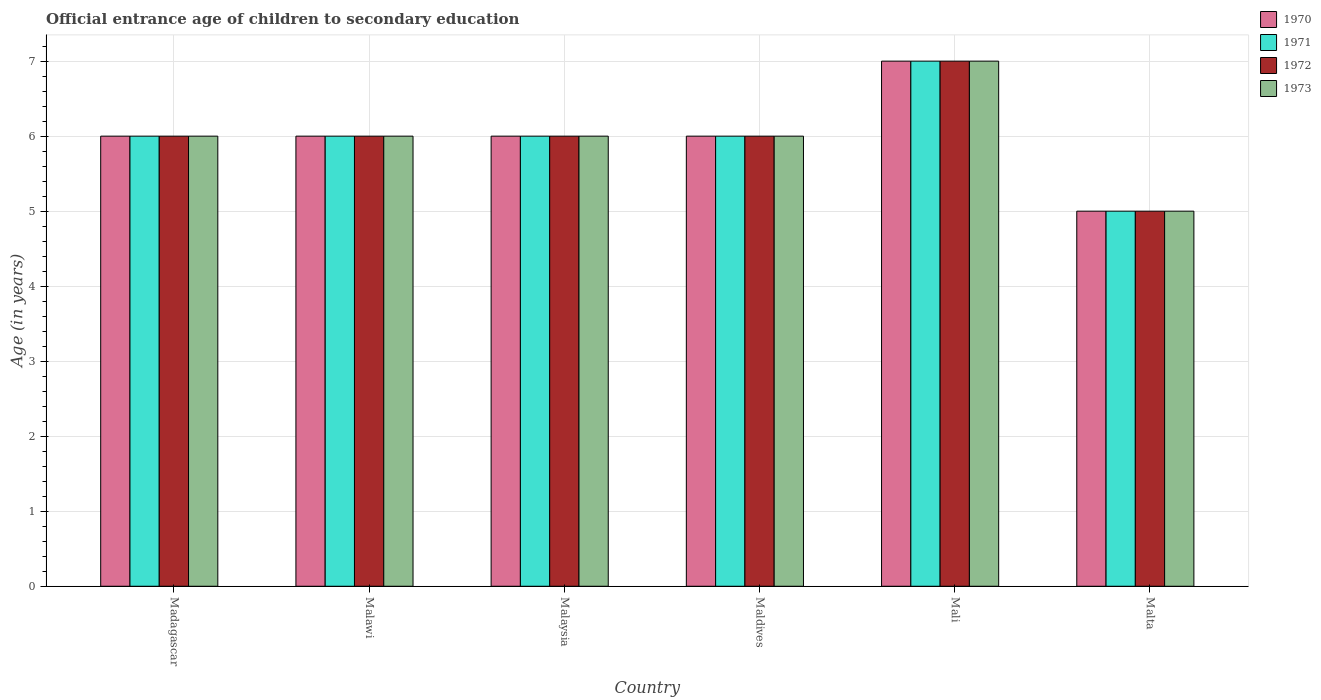How many bars are there on the 3rd tick from the right?
Provide a short and direct response. 4. What is the label of the 2nd group of bars from the left?
Offer a very short reply. Malawi. What is the secondary school starting age of children in 1972 in Madagascar?
Provide a succinct answer. 6. In which country was the secondary school starting age of children in 1972 maximum?
Your answer should be very brief. Mali. In which country was the secondary school starting age of children in 1971 minimum?
Provide a short and direct response. Malta. What is the average secondary school starting age of children in 1972 per country?
Your answer should be compact. 6. What is the difference between the secondary school starting age of children of/in 1972 and secondary school starting age of children of/in 1970 in Maldives?
Provide a short and direct response. 0. In how many countries, is the secondary school starting age of children in 1972 greater than 2 years?
Give a very brief answer. 6. What is the ratio of the secondary school starting age of children in 1972 in Malawi to that in Mali?
Your answer should be compact. 0.86. Is the secondary school starting age of children in 1972 in Madagascar less than that in Malta?
Your answer should be compact. No. Is the difference between the secondary school starting age of children in 1972 in Madagascar and Malaysia greater than the difference between the secondary school starting age of children in 1970 in Madagascar and Malaysia?
Your answer should be very brief. No. What is the difference between the highest and the second highest secondary school starting age of children in 1972?
Provide a succinct answer. -1. What is the difference between the highest and the lowest secondary school starting age of children in 1973?
Ensure brevity in your answer.  2. Is the sum of the secondary school starting age of children in 1973 in Malaysia and Maldives greater than the maximum secondary school starting age of children in 1972 across all countries?
Provide a succinct answer. Yes. Is it the case that in every country, the sum of the secondary school starting age of children in 1973 and secondary school starting age of children in 1970 is greater than the sum of secondary school starting age of children in 1972 and secondary school starting age of children in 1971?
Your answer should be compact. No. What does the 3rd bar from the right in Malaysia represents?
Keep it short and to the point. 1971. Are all the bars in the graph horizontal?
Make the answer very short. No. What is the difference between two consecutive major ticks on the Y-axis?
Offer a terse response. 1. Does the graph contain grids?
Make the answer very short. Yes. Where does the legend appear in the graph?
Provide a succinct answer. Top right. How many legend labels are there?
Your answer should be compact. 4. How are the legend labels stacked?
Offer a very short reply. Vertical. What is the title of the graph?
Provide a succinct answer. Official entrance age of children to secondary education. Does "1981" appear as one of the legend labels in the graph?
Offer a terse response. No. What is the label or title of the Y-axis?
Make the answer very short. Age (in years). What is the Age (in years) of 1970 in Madagascar?
Your answer should be very brief. 6. What is the Age (in years) in 1971 in Madagascar?
Your response must be concise. 6. What is the Age (in years) of 1973 in Madagascar?
Your answer should be very brief. 6. What is the Age (in years) in 1970 in Malawi?
Your response must be concise. 6. What is the Age (in years) in 1973 in Malawi?
Offer a terse response. 6. What is the Age (in years) in 1973 in Malaysia?
Provide a short and direct response. 6. What is the Age (in years) of 1971 in Maldives?
Your answer should be compact. 6. What is the Age (in years) in 1972 in Maldives?
Your answer should be very brief. 6. What is the Age (in years) in 1973 in Maldives?
Your answer should be compact. 6. What is the Age (in years) of 1971 in Mali?
Make the answer very short. 7. What is the Age (in years) in 1972 in Mali?
Offer a terse response. 7. What is the Age (in years) of 1973 in Mali?
Provide a succinct answer. 7. What is the Age (in years) in 1970 in Malta?
Offer a very short reply. 5. What is the Age (in years) of 1973 in Malta?
Your response must be concise. 5. Across all countries, what is the maximum Age (in years) in 1973?
Make the answer very short. 7. Across all countries, what is the minimum Age (in years) of 1970?
Your response must be concise. 5. Across all countries, what is the minimum Age (in years) of 1971?
Provide a short and direct response. 5. Across all countries, what is the minimum Age (in years) of 1973?
Give a very brief answer. 5. What is the total Age (in years) in 1971 in the graph?
Offer a terse response. 36. What is the difference between the Age (in years) in 1971 in Madagascar and that in Malawi?
Offer a very short reply. 0. What is the difference between the Age (in years) of 1972 in Madagascar and that in Malawi?
Offer a terse response. 0. What is the difference between the Age (in years) in 1973 in Madagascar and that in Malawi?
Provide a short and direct response. 0. What is the difference between the Age (in years) of 1972 in Madagascar and that in Malaysia?
Give a very brief answer. 0. What is the difference between the Age (in years) of 1973 in Madagascar and that in Malaysia?
Provide a succinct answer. 0. What is the difference between the Age (in years) of 1970 in Madagascar and that in Maldives?
Keep it short and to the point. 0. What is the difference between the Age (in years) in 1971 in Madagascar and that in Maldives?
Ensure brevity in your answer.  0. What is the difference between the Age (in years) in 1973 in Madagascar and that in Maldives?
Your answer should be very brief. 0. What is the difference between the Age (in years) of 1970 in Madagascar and that in Mali?
Offer a terse response. -1. What is the difference between the Age (in years) in 1971 in Madagascar and that in Mali?
Provide a short and direct response. -1. What is the difference between the Age (in years) of 1973 in Madagascar and that in Mali?
Offer a very short reply. -1. What is the difference between the Age (in years) in 1970 in Madagascar and that in Malta?
Provide a succinct answer. 1. What is the difference between the Age (in years) in 1971 in Malawi and that in Malaysia?
Keep it short and to the point. 0. What is the difference between the Age (in years) in 1972 in Malawi and that in Malaysia?
Make the answer very short. 0. What is the difference between the Age (in years) of 1970 in Malawi and that in Maldives?
Keep it short and to the point. 0. What is the difference between the Age (in years) of 1971 in Malawi and that in Maldives?
Provide a succinct answer. 0. What is the difference between the Age (in years) of 1973 in Malawi and that in Maldives?
Provide a succinct answer. 0. What is the difference between the Age (in years) of 1971 in Malawi and that in Mali?
Your answer should be compact. -1. What is the difference between the Age (in years) in 1970 in Malawi and that in Malta?
Ensure brevity in your answer.  1. What is the difference between the Age (in years) in 1971 in Malaysia and that in Maldives?
Offer a very short reply. 0. What is the difference between the Age (in years) in 1972 in Malaysia and that in Maldives?
Provide a short and direct response. 0. What is the difference between the Age (in years) of 1973 in Malaysia and that in Maldives?
Make the answer very short. 0. What is the difference between the Age (in years) in 1970 in Malaysia and that in Mali?
Make the answer very short. -1. What is the difference between the Age (in years) of 1970 in Malaysia and that in Malta?
Ensure brevity in your answer.  1. What is the difference between the Age (in years) in 1972 in Malaysia and that in Malta?
Your answer should be compact. 1. What is the difference between the Age (in years) in 1973 in Malaysia and that in Malta?
Provide a short and direct response. 1. What is the difference between the Age (in years) of 1972 in Maldives and that in Mali?
Your response must be concise. -1. What is the difference between the Age (in years) in 1970 in Maldives and that in Malta?
Keep it short and to the point. 1. What is the difference between the Age (in years) of 1970 in Madagascar and the Age (in years) of 1971 in Malawi?
Offer a very short reply. 0. What is the difference between the Age (in years) of 1970 in Madagascar and the Age (in years) of 1972 in Malawi?
Offer a very short reply. 0. What is the difference between the Age (in years) in 1971 in Madagascar and the Age (in years) in 1973 in Malawi?
Ensure brevity in your answer.  0. What is the difference between the Age (in years) in 1972 in Madagascar and the Age (in years) in 1973 in Malawi?
Your answer should be compact. 0. What is the difference between the Age (in years) of 1970 in Madagascar and the Age (in years) of 1971 in Malaysia?
Provide a succinct answer. 0. What is the difference between the Age (in years) in 1970 in Madagascar and the Age (in years) in 1972 in Malaysia?
Your answer should be very brief. 0. What is the difference between the Age (in years) in 1971 in Madagascar and the Age (in years) in 1972 in Malaysia?
Ensure brevity in your answer.  0. What is the difference between the Age (in years) of 1971 in Madagascar and the Age (in years) of 1973 in Malaysia?
Give a very brief answer. 0. What is the difference between the Age (in years) of 1972 in Madagascar and the Age (in years) of 1973 in Malaysia?
Ensure brevity in your answer.  0. What is the difference between the Age (in years) of 1970 in Madagascar and the Age (in years) of 1971 in Maldives?
Offer a terse response. 0. What is the difference between the Age (in years) of 1970 in Madagascar and the Age (in years) of 1972 in Maldives?
Offer a terse response. 0. What is the difference between the Age (in years) of 1970 in Madagascar and the Age (in years) of 1973 in Maldives?
Ensure brevity in your answer.  0. What is the difference between the Age (in years) in 1972 in Madagascar and the Age (in years) in 1973 in Maldives?
Provide a succinct answer. 0. What is the difference between the Age (in years) of 1970 in Madagascar and the Age (in years) of 1973 in Mali?
Keep it short and to the point. -1. What is the difference between the Age (in years) of 1971 in Madagascar and the Age (in years) of 1972 in Mali?
Your response must be concise. -1. What is the difference between the Age (in years) of 1971 in Madagascar and the Age (in years) of 1973 in Mali?
Make the answer very short. -1. What is the difference between the Age (in years) in 1970 in Madagascar and the Age (in years) in 1971 in Malta?
Provide a succinct answer. 1. What is the difference between the Age (in years) of 1970 in Malawi and the Age (in years) of 1972 in Malaysia?
Make the answer very short. 0. What is the difference between the Age (in years) of 1970 in Malawi and the Age (in years) of 1973 in Malaysia?
Provide a succinct answer. 0. What is the difference between the Age (in years) in 1971 in Malawi and the Age (in years) in 1973 in Malaysia?
Keep it short and to the point. 0. What is the difference between the Age (in years) of 1972 in Malawi and the Age (in years) of 1973 in Malaysia?
Keep it short and to the point. 0. What is the difference between the Age (in years) of 1970 in Malawi and the Age (in years) of 1971 in Maldives?
Ensure brevity in your answer.  0. What is the difference between the Age (in years) in 1971 in Malawi and the Age (in years) in 1972 in Maldives?
Give a very brief answer. 0. What is the difference between the Age (in years) in 1972 in Malawi and the Age (in years) in 1973 in Maldives?
Offer a very short reply. 0. What is the difference between the Age (in years) in 1970 in Malawi and the Age (in years) in 1971 in Mali?
Your response must be concise. -1. What is the difference between the Age (in years) in 1970 in Malawi and the Age (in years) in 1972 in Mali?
Give a very brief answer. -1. What is the difference between the Age (in years) of 1971 in Malawi and the Age (in years) of 1973 in Mali?
Ensure brevity in your answer.  -1. What is the difference between the Age (in years) in 1970 in Malawi and the Age (in years) in 1971 in Malta?
Keep it short and to the point. 1. What is the difference between the Age (in years) in 1970 in Malawi and the Age (in years) in 1972 in Malta?
Give a very brief answer. 1. What is the difference between the Age (in years) in 1971 in Malawi and the Age (in years) in 1973 in Malta?
Your answer should be compact. 1. What is the difference between the Age (in years) in 1972 in Malawi and the Age (in years) in 1973 in Malta?
Keep it short and to the point. 1. What is the difference between the Age (in years) of 1970 in Malaysia and the Age (in years) of 1971 in Maldives?
Give a very brief answer. 0. What is the difference between the Age (in years) in 1970 in Malaysia and the Age (in years) in 1972 in Maldives?
Provide a short and direct response. 0. What is the difference between the Age (in years) of 1971 in Malaysia and the Age (in years) of 1972 in Maldives?
Your answer should be very brief. 0. What is the difference between the Age (in years) of 1970 in Malaysia and the Age (in years) of 1971 in Mali?
Your answer should be compact. -1. What is the difference between the Age (in years) of 1970 in Malaysia and the Age (in years) of 1972 in Mali?
Ensure brevity in your answer.  -1. What is the difference between the Age (in years) in 1970 in Malaysia and the Age (in years) in 1973 in Mali?
Your answer should be very brief. -1. What is the difference between the Age (in years) in 1971 in Malaysia and the Age (in years) in 1973 in Mali?
Your answer should be very brief. -1. What is the difference between the Age (in years) of 1970 in Malaysia and the Age (in years) of 1971 in Malta?
Offer a terse response. 1. What is the difference between the Age (in years) in 1971 in Malaysia and the Age (in years) in 1972 in Malta?
Make the answer very short. 1. What is the difference between the Age (in years) in 1972 in Malaysia and the Age (in years) in 1973 in Malta?
Keep it short and to the point. 1. What is the difference between the Age (in years) in 1970 in Maldives and the Age (in years) in 1972 in Mali?
Your answer should be compact. -1. What is the difference between the Age (in years) of 1971 in Maldives and the Age (in years) of 1973 in Mali?
Your answer should be very brief. -1. What is the difference between the Age (in years) in 1970 in Maldives and the Age (in years) in 1971 in Malta?
Provide a short and direct response. 1. What is the difference between the Age (in years) of 1970 in Maldives and the Age (in years) of 1972 in Malta?
Give a very brief answer. 1. What is the difference between the Age (in years) of 1971 in Maldives and the Age (in years) of 1972 in Malta?
Give a very brief answer. 1. What is the difference between the Age (in years) in 1971 in Maldives and the Age (in years) in 1973 in Malta?
Ensure brevity in your answer.  1. What is the difference between the Age (in years) in 1972 in Maldives and the Age (in years) in 1973 in Malta?
Your answer should be very brief. 1. What is the difference between the Age (in years) of 1971 in Mali and the Age (in years) of 1972 in Malta?
Offer a terse response. 2. What is the difference between the Age (in years) of 1971 in Mali and the Age (in years) of 1973 in Malta?
Keep it short and to the point. 2. What is the difference between the Age (in years) in 1970 and Age (in years) in 1973 in Madagascar?
Your response must be concise. 0. What is the difference between the Age (in years) of 1971 and Age (in years) of 1973 in Madagascar?
Ensure brevity in your answer.  0. What is the difference between the Age (in years) of 1970 and Age (in years) of 1971 in Malawi?
Offer a very short reply. 0. What is the difference between the Age (in years) in 1971 and Age (in years) in 1973 in Malawi?
Give a very brief answer. 0. What is the difference between the Age (in years) in 1972 and Age (in years) in 1973 in Malawi?
Your answer should be very brief. 0. What is the difference between the Age (in years) in 1970 and Age (in years) in 1973 in Malaysia?
Offer a very short reply. 0. What is the difference between the Age (in years) of 1971 and Age (in years) of 1973 in Malaysia?
Provide a succinct answer. 0. What is the difference between the Age (in years) of 1972 and Age (in years) of 1973 in Malaysia?
Make the answer very short. 0. What is the difference between the Age (in years) in 1972 and Age (in years) in 1973 in Maldives?
Provide a succinct answer. 0. What is the difference between the Age (in years) of 1970 and Age (in years) of 1971 in Mali?
Your answer should be compact. 0. What is the difference between the Age (in years) of 1970 and Age (in years) of 1972 in Mali?
Your answer should be compact. 0. What is the difference between the Age (in years) in 1972 and Age (in years) in 1973 in Mali?
Offer a very short reply. 0. What is the difference between the Age (in years) in 1970 and Age (in years) in 1971 in Malta?
Ensure brevity in your answer.  0. What is the difference between the Age (in years) of 1970 and Age (in years) of 1973 in Malta?
Provide a short and direct response. 0. What is the difference between the Age (in years) in 1971 and Age (in years) in 1972 in Malta?
Make the answer very short. 0. What is the difference between the Age (in years) in 1971 and Age (in years) in 1973 in Malta?
Your answer should be compact. 0. What is the ratio of the Age (in years) in 1970 in Madagascar to that in Malawi?
Your response must be concise. 1. What is the ratio of the Age (in years) in 1971 in Madagascar to that in Malawi?
Your response must be concise. 1. What is the ratio of the Age (in years) of 1972 in Madagascar to that in Malaysia?
Provide a short and direct response. 1. What is the ratio of the Age (in years) in 1973 in Madagascar to that in Malaysia?
Your response must be concise. 1. What is the ratio of the Age (in years) of 1971 in Madagascar to that in Maldives?
Make the answer very short. 1. What is the ratio of the Age (in years) in 1972 in Madagascar to that in Maldives?
Offer a terse response. 1. What is the ratio of the Age (in years) in 1973 in Madagascar to that in Maldives?
Your answer should be very brief. 1. What is the ratio of the Age (in years) of 1970 in Madagascar to that in Mali?
Offer a very short reply. 0.86. What is the ratio of the Age (in years) of 1971 in Madagascar to that in Mali?
Your answer should be compact. 0.86. What is the ratio of the Age (in years) in 1972 in Madagascar to that in Mali?
Your response must be concise. 0.86. What is the ratio of the Age (in years) of 1971 in Madagascar to that in Malta?
Make the answer very short. 1.2. What is the ratio of the Age (in years) of 1970 in Malawi to that in Malaysia?
Offer a terse response. 1. What is the ratio of the Age (in years) in 1972 in Malawi to that in Malaysia?
Give a very brief answer. 1. What is the ratio of the Age (in years) in 1973 in Malawi to that in Malaysia?
Ensure brevity in your answer.  1. What is the ratio of the Age (in years) in 1971 in Malawi to that in Maldives?
Offer a very short reply. 1. What is the ratio of the Age (in years) of 1972 in Malawi to that in Maldives?
Make the answer very short. 1. What is the ratio of the Age (in years) in 1970 in Malawi to that in Mali?
Offer a very short reply. 0.86. What is the ratio of the Age (in years) in 1971 in Malawi to that in Mali?
Offer a very short reply. 0.86. What is the ratio of the Age (in years) in 1972 in Malawi to that in Mali?
Give a very brief answer. 0.86. What is the ratio of the Age (in years) in 1970 in Malawi to that in Malta?
Keep it short and to the point. 1.2. What is the ratio of the Age (in years) of 1971 in Malawi to that in Malta?
Your response must be concise. 1.2. What is the ratio of the Age (in years) of 1972 in Malawi to that in Malta?
Offer a very short reply. 1.2. What is the ratio of the Age (in years) in 1970 in Malaysia to that in Maldives?
Provide a short and direct response. 1. What is the ratio of the Age (in years) of 1972 in Malaysia to that in Maldives?
Your answer should be compact. 1. What is the ratio of the Age (in years) of 1973 in Malaysia to that in Maldives?
Your response must be concise. 1. What is the ratio of the Age (in years) of 1971 in Malaysia to that in Mali?
Offer a terse response. 0.86. What is the ratio of the Age (in years) in 1972 in Malaysia to that in Mali?
Offer a very short reply. 0.86. What is the ratio of the Age (in years) of 1970 in Malaysia to that in Malta?
Offer a very short reply. 1.2. What is the ratio of the Age (in years) in 1971 in Malaysia to that in Malta?
Keep it short and to the point. 1.2. What is the ratio of the Age (in years) in 1971 in Maldives to that in Mali?
Your answer should be compact. 0.86. What is the ratio of the Age (in years) in 1973 in Maldives to that in Mali?
Provide a short and direct response. 0.86. What is the ratio of the Age (in years) of 1972 in Maldives to that in Malta?
Make the answer very short. 1.2. What is the ratio of the Age (in years) in 1973 in Maldives to that in Malta?
Keep it short and to the point. 1.2. What is the ratio of the Age (in years) of 1970 in Mali to that in Malta?
Your answer should be compact. 1.4. What is the ratio of the Age (in years) of 1971 in Mali to that in Malta?
Give a very brief answer. 1.4. What is the ratio of the Age (in years) of 1972 in Mali to that in Malta?
Offer a very short reply. 1.4. What is the difference between the highest and the second highest Age (in years) in 1970?
Your answer should be very brief. 1. What is the difference between the highest and the second highest Age (in years) in 1972?
Your answer should be compact. 1. What is the difference between the highest and the second highest Age (in years) in 1973?
Offer a very short reply. 1. What is the difference between the highest and the lowest Age (in years) in 1970?
Give a very brief answer. 2. What is the difference between the highest and the lowest Age (in years) of 1971?
Your answer should be very brief. 2. 